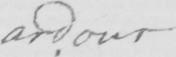Can you read and transcribe this handwriting? ardour 